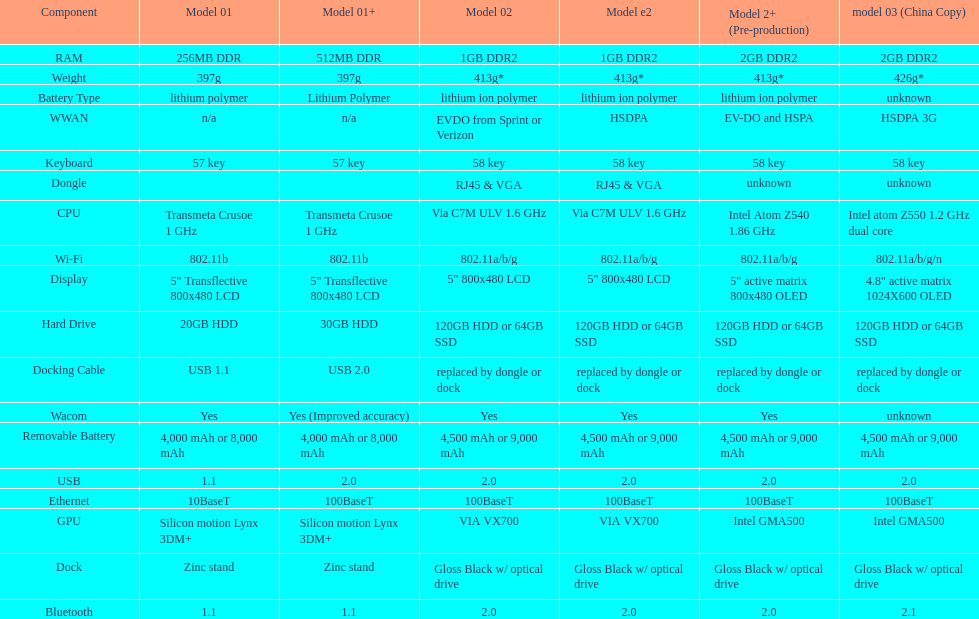What is the next highest hard drive available after the 30gb model? 64GB SSD. I'm looking to parse the entire table for insights. Could you assist me with that? {'header': ['Component', 'Model 01', 'Model 01+', 'Model 02', 'Model e2', 'Model 2+ (Pre-production)', 'model 03 (China Copy)'], 'rows': [['RAM', '256MB DDR', '512MB DDR', '1GB DDR2', '1GB DDR2', '2GB DDR2', '2GB DDR2'], ['Weight', '397g', '397g', '413g*', '413g*', '413g*', '426g*'], ['Battery Type', 'lithium polymer', 'Lithium Polymer', 'lithium ion polymer', 'lithium ion polymer', 'lithium ion polymer', 'unknown'], ['WWAN', 'n/a', 'n/a', 'EVDO from Sprint or Verizon', 'HSDPA', 'EV-DO and HSPA', 'HSDPA 3G'], ['Keyboard', '57 key', '57 key', '58 key', '58 key', '58 key', '58 key'], ['Dongle', '', '', 'RJ45 & VGA', 'RJ45 & VGA', 'unknown', 'unknown'], ['CPU', 'Transmeta Crusoe 1\xa0GHz', 'Transmeta Crusoe 1\xa0GHz', 'Via C7M ULV 1.6\xa0GHz', 'Via C7M ULV 1.6\xa0GHz', 'Intel Atom Z540 1.86\xa0GHz', 'Intel atom Z550 1.2\xa0GHz dual core'], ['Wi-Fi', '802.11b', '802.11b', '802.11a/b/g', '802.11a/b/g', '802.11a/b/g', '802.11a/b/g/n'], ['Display', '5" Transflective 800x480 LCD', '5" Transflective 800x480 LCD', '5" 800x480 LCD', '5" 800x480 LCD', '5" active matrix 800x480 OLED', '4.8" active matrix 1024X600 OLED'], ['Hard Drive', '20GB HDD', '30GB HDD', '120GB HDD or 64GB SSD', '120GB HDD or 64GB SSD', '120GB HDD or 64GB SSD', '120GB HDD or 64GB SSD'], ['Docking Cable', 'USB 1.1', 'USB 2.0', 'replaced by dongle or dock', 'replaced by dongle or dock', 'replaced by dongle or dock', 'replaced by dongle or dock'], ['Wacom', 'Yes', 'Yes (Improved accuracy)', 'Yes', 'Yes', 'Yes', 'unknown'], ['Removable Battery', '4,000 mAh or 8,000 mAh', '4,000 mAh or 8,000 mAh', '4,500 mAh or 9,000 mAh', '4,500 mAh or 9,000 mAh', '4,500 mAh or 9,000 mAh', '4,500 mAh or 9,000 mAh'], ['USB', '1.1', '2.0', '2.0', '2.0', '2.0', '2.0'], ['Ethernet', '10BaseT', '100BaseT', '100BaseT', '100BaseT', '100BaseT', '100BaseT'], ['GPU', 'Silicon motion Lynx 3DM+', 'Silicon motion Lynx 3DM+', 'VIA VX700', 'VIA VX700', 'Intel GMA500', 'Intel GMA500'], ['Dock', 'Zinc stand', 'Zinc stand', 'Gloss Black w/ optical drive', 'Gloss Black w/ optical drive', 'Gloss Black w/ optical drive', 'Gloss Black w/ optical drive'], ['Bluetooth', '1.1', '1.1', '2.0', '2.0', '2.0', '2.1']]} 